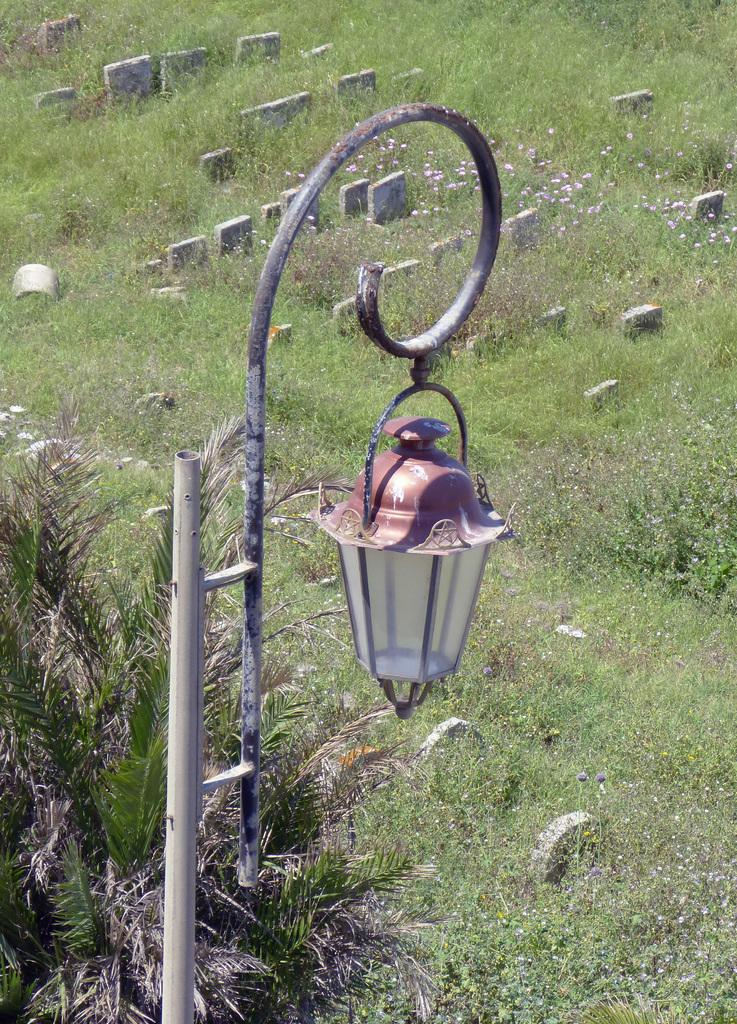Where was the picture taken? The picture was taken outside. What can be seen in the foreground of the image? There are plants in the foreground. Can you describe the lighting fixture in the image? A lamp is hanging on a metal rod. What type of vegetation is visible in the image? There is green grass visible. What other unspecified objects can be seen in the image? There are other unspecified objects in the image, but their details are not provided. Can you tell me how many giraffes are visible in the image? There are no giraffes present in the image. What type of guide is shown assisting the people in the image? There are no people or guides present in the image. 